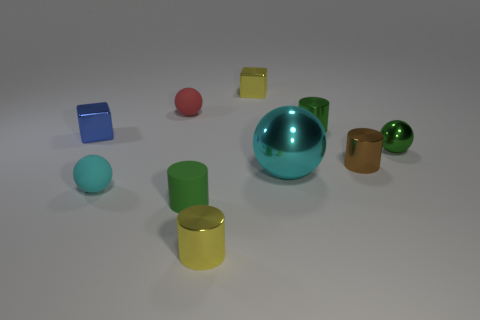Are there any other things that have the same size as the cyan shiny ball?
Offer a very short reply. No. Is the tiny yellow cylinder made of the same material as the yellow block?
Provide a short and direct response. Yes. What size is the other cyan object that is the same shape as the large cyan object?
Offer a terse response. Small. How many things are either spheres on the right side of the tiny green matte object or matte spheres in front of the brown cylinder?
Offer a terse response. 3. Is the number of spheres less than the number of big matte blocks?
Give a very brief answer. No. There is a green metallic cylinder; is it the same size as the yellow shiny object in front of the green sphere?
Make the answer very short. Yes. What number of matte objects are either yellow cubes or large cylinders?
Keep it short and to the point. 0. Are there more matte objects than big green spheres?
Your response must be concise. Yes. The ball that is the same color as the large metal object is what size?
Your response must be concise. Small. The small yellow shiny thing that is behind the yellow thing in front of the big cyan sphere is what shape?
Give a very brief answer. Cube. 